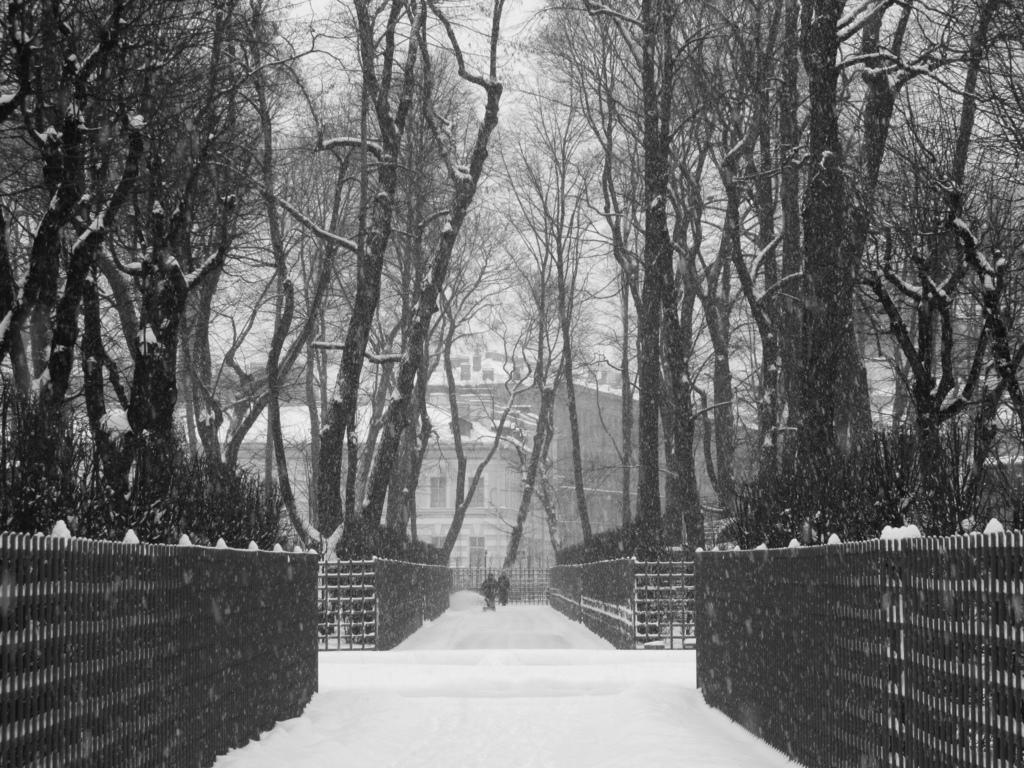What is the color scheme of the image? The image is black and white. What type of weather is depicted in the image? There is snow in the image. What natural elements can be seen in the image? There are trees in the image. What man-made structure is present in the image? There is a building in the image. What architectural feature is visible in the image? There is a fence in the image. How many people are in the image? There are two persons in the image. What is visible in the background of the image? The sky is visible in the background of the image. What type of grain is being harvested by the coach in the image? There is no coach or grain present in the image. What is the range of the persons in the image? The image does not provide information about the range of the persons; it only shows their presence. 